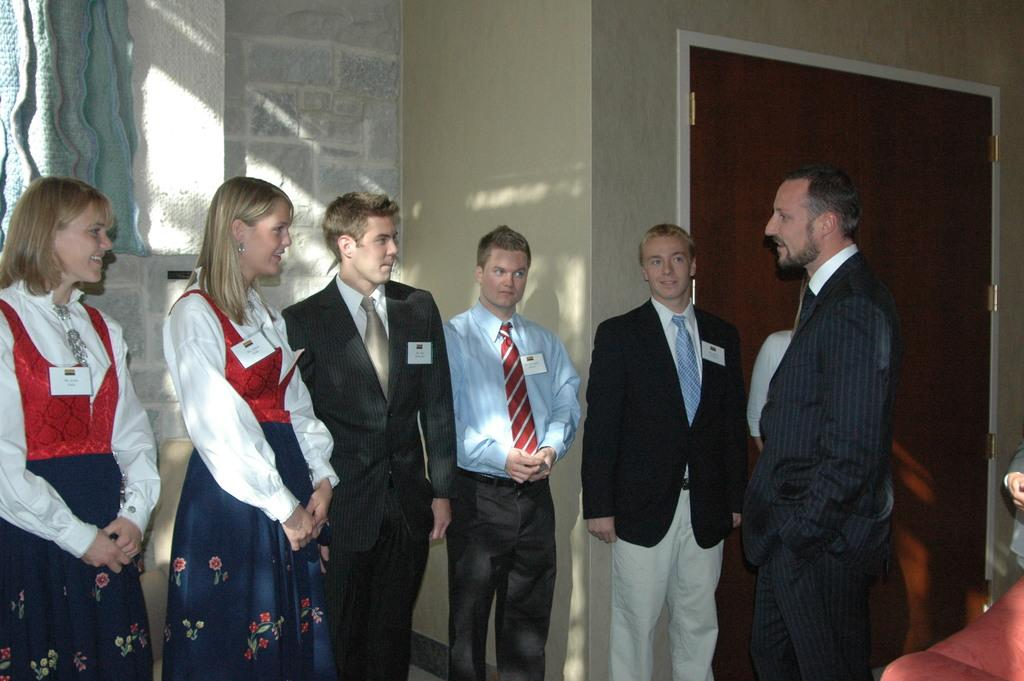How many people are in the image? There is a group of people standing in the image, so there are multiple people present. What type of structure can be seen in the image? There are walls visible in the image, which suggests a building or enclosed space. What type of window treatment is present in the image? There is a curtain in the image. What can be found in the bottom right corner of the image? There is an object in the bottom right corner of the image. Can you confirm the presence of a person in the image? Yes, there is a person in the image. What type of leaf is being used as a train ticket by the person in the image? There is no leaf or train ticket present in the image; it only features a group of people, walls, a curtain, and an object in the bottom right corner. 